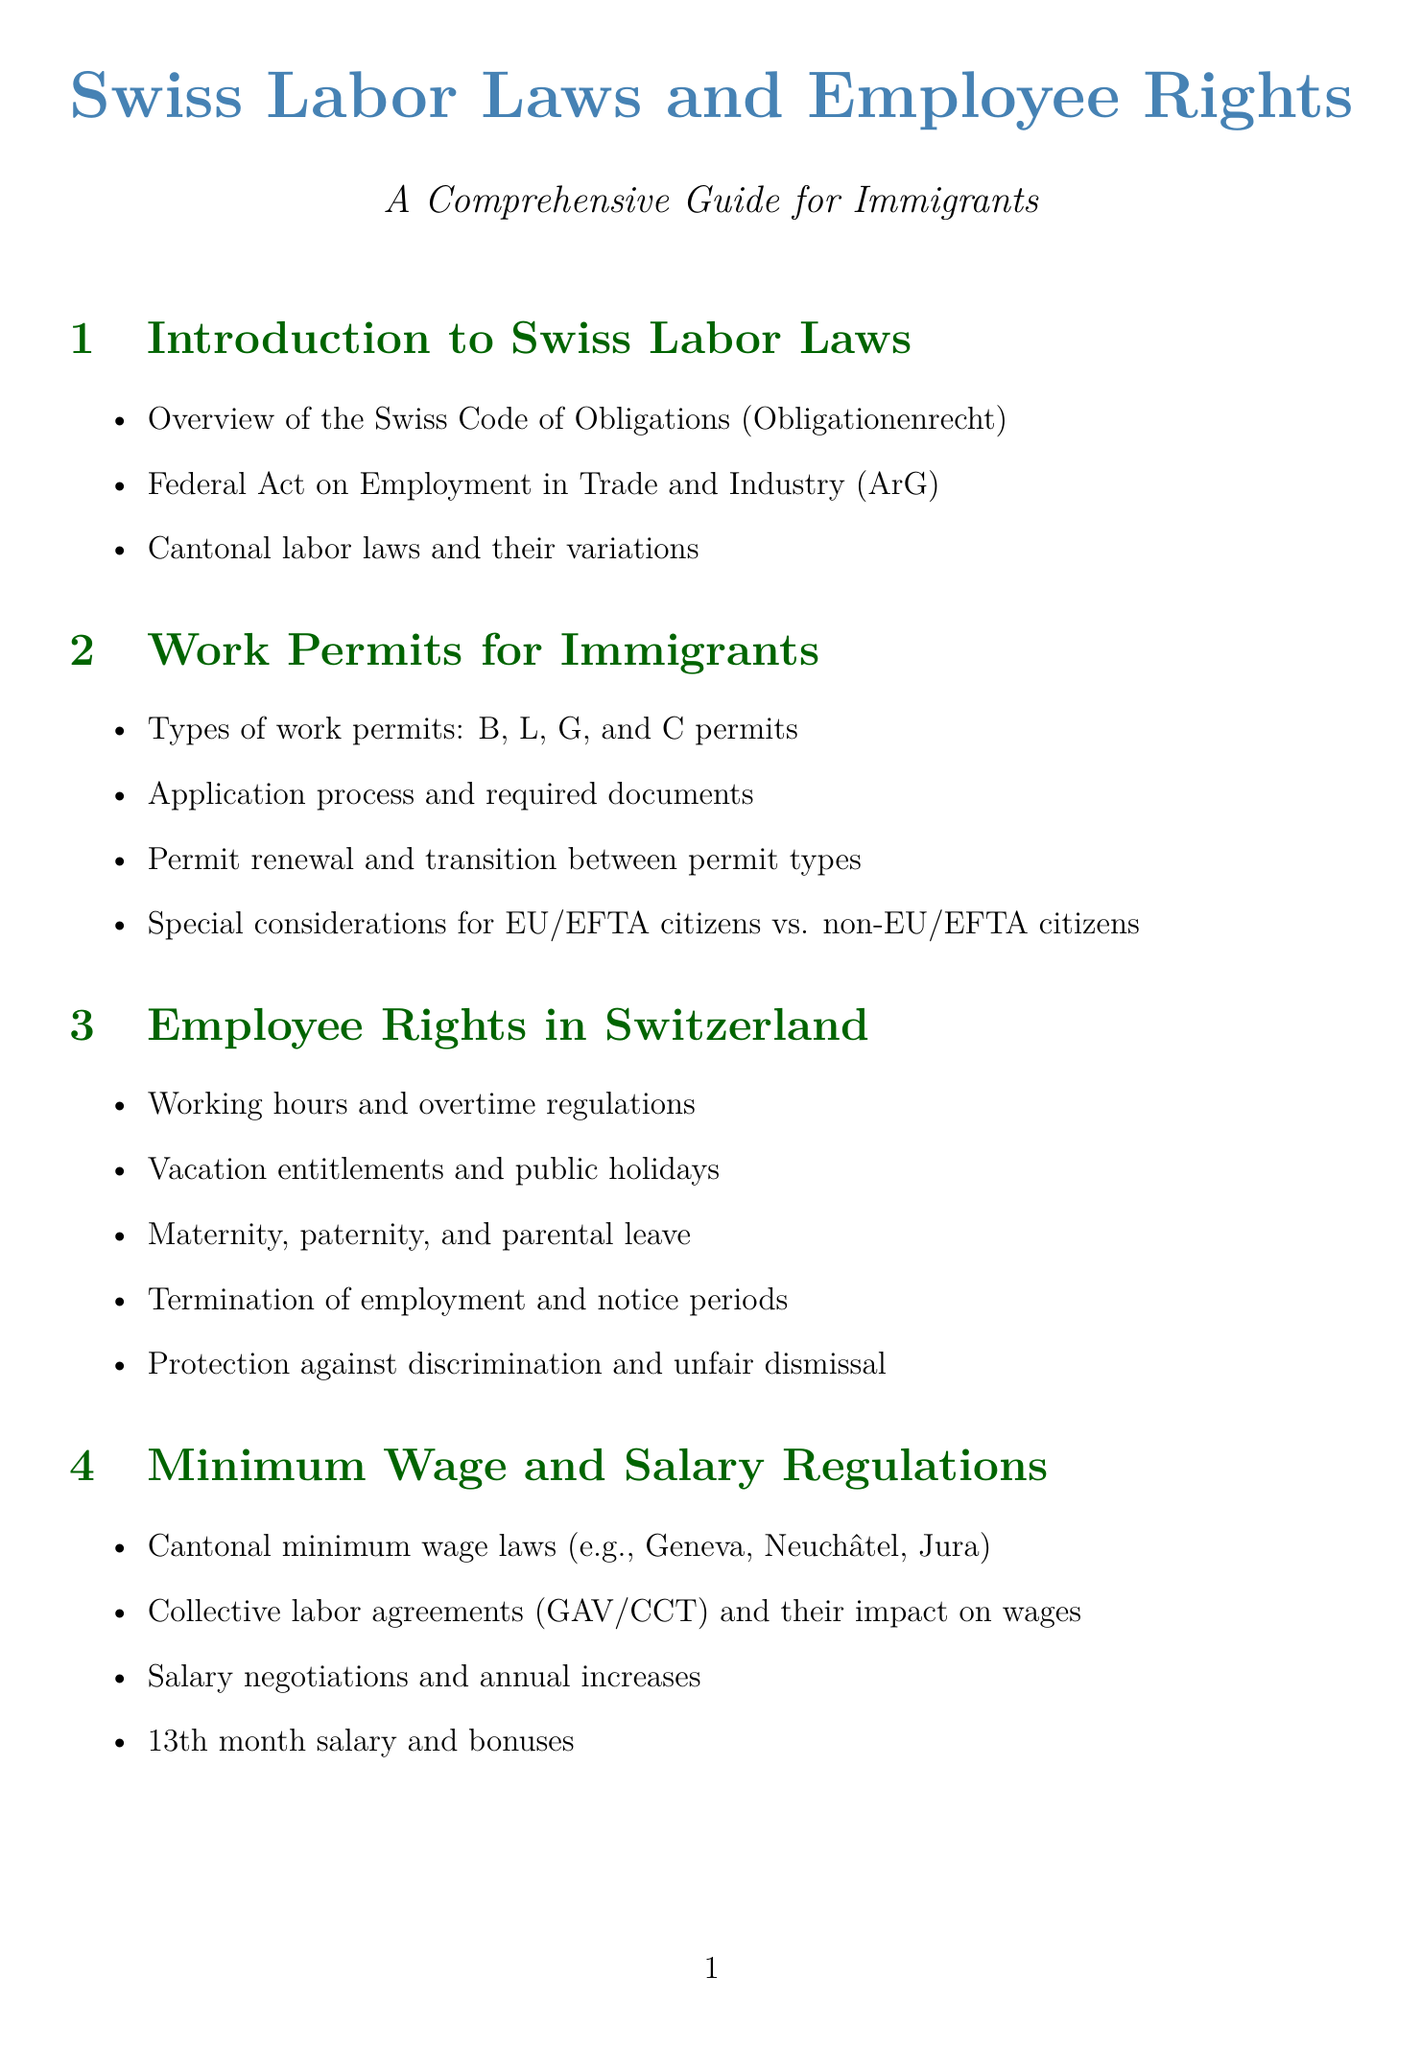What is the purpose of the manual? The purpose is to provide guidance on Swiss labor laws, work permits, and employee rights specifically for immigrants.
Answer: guidance on Swiss labor laws What types of work permits are mentioned? The types of work permits listed include B, L, G, and C permits.
Answer: B, L, G, and C permits What does AHV stand for? AHV stands for Old Age and Survivors' Insurance.
Answer: Old Age and Survivors' Insurance Which section covers taxation for low-income workers? The section titled "Taxation for Low-Income Workers" specifically addresses this topic.
Answer: Taxation for Low-Income Workers What are the eligibility criteria discussed in the manual? The manual outlines the eligibility criteria for social assistance in the section "State Aid and Social Assistance."
Answer: eligibility criteria for social assistance What is the significance of integration courses for immigrants? Integration courses are important for permit renewal as per the "Language and Integration Requirements" section.
Answer: permit renewal What type of organizations are mentioned for support? The manual mentions trade unions and migrant workers' support organizations as sources of help.
Answer: trade unions and migrant workers' support organizations Which section contains information about minimum wage laws? The section "Minimum Wage and Salary Regulations" contains this information.
Answer: Minimum Wage and Salary Regulations What does the acronym IV represent? IV represents Disability Insurance.
Answer: Disability Insurance 